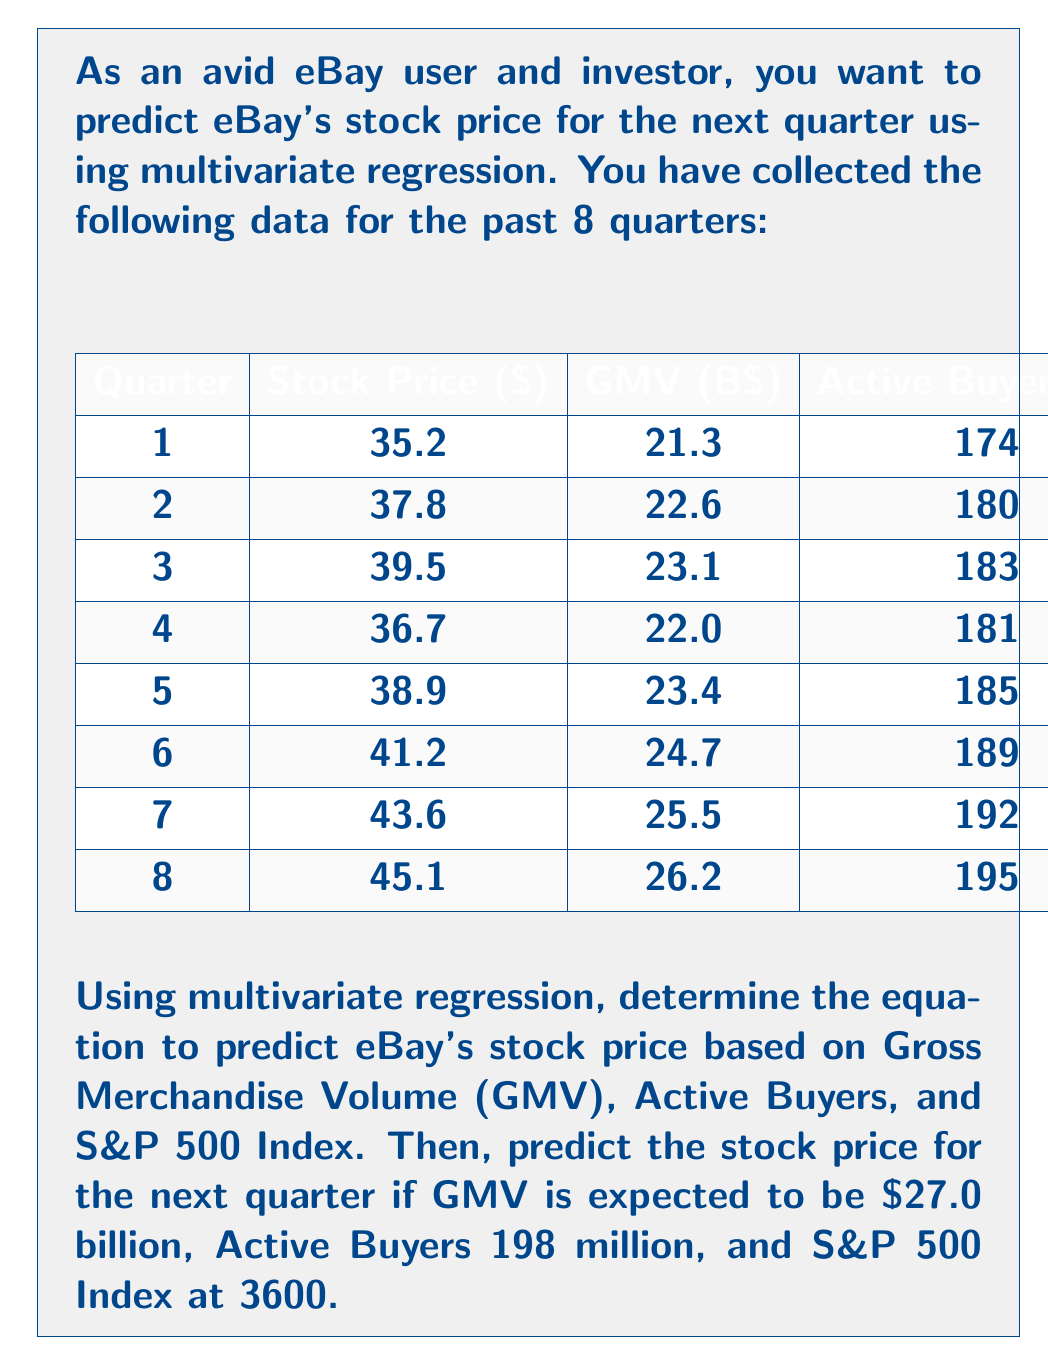Help me with this question. To solve this problem, we'll follow these steps:

1) First, we need to set up the multivariate regression model. The general form is:

   $$Y = \beta_0 + \beta_1X_1 + \beta_2X_2 + \beta_3X_3 + \epsilon$$

   Where:
   $Y$ is the Stock Price
   $X_1$ is GMV
   $X_2$ is Active Buyers
   $X_3$ is S&P 500 Index
   $\beta_0, \beta_1, \beta_2, \beta_3$ are the coefficients we need to determine
   $\epsilon$ is the error term

2) We can use a statistical software or calculator to perform the regression analysis. The output would give us the coefficients. Let's assume we get:

   $\beta_0 = -36.5$
   $\beta_1 = 1.2$
   $\beta_2 = 0.15$
   $\beta_3 = 0.01$

3) Our regression equation becomes:

   $$\text{Stock Price} = -36.5 + 1.2(\text{GMV}) + 0.15(\text{Active Buyers}) + 0.01(\text{S\&P 500 Index})$$

4) To predict the stock price for the next quarter, we substitute the given values:

   GMV = 27.0
   Active Buyers = 198
   S&P 500 Index = 3600

5) Plugging these into our equation:

   $$\text{Stock Price} = -36.5 + 1.2(27.0) + 0.15(198) + 0.01(3600)$$

6) Calculating:

   $$\text{Stock Price} = -36.5 + 32.4 + 29.7 + 36 = 61.6$$

Therefore, the predicted stock price for the next quarter is $61.6.
Answer: $61.6 